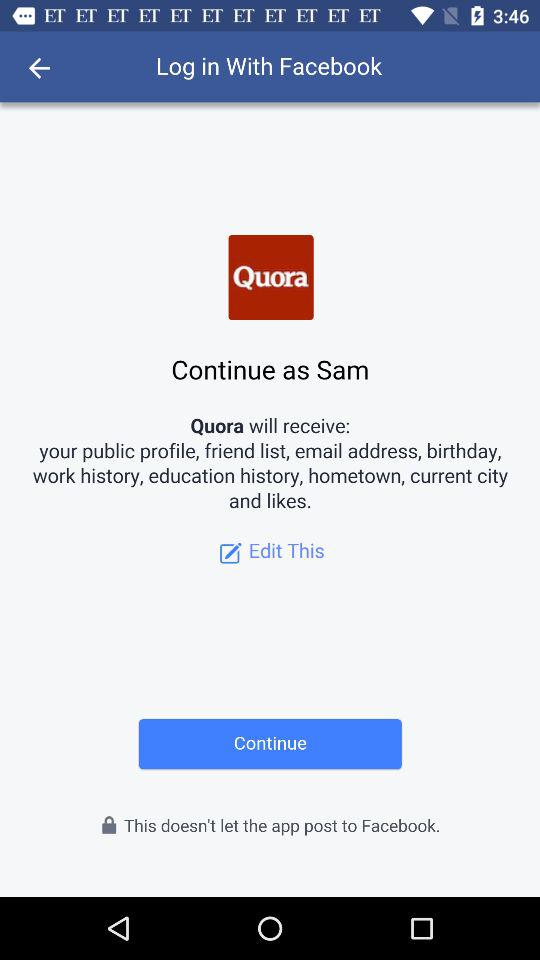What application is asking for permission? The application asking for permission is "Quora". 